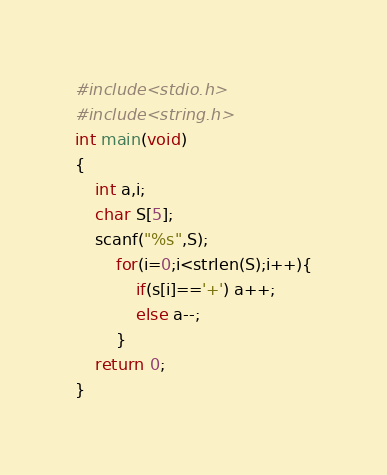<code> <loc_0><loc_0><loc_500><loc_500><_C_>#include<stdio.h>
#include<string.h>
int main(void)
{
	int a,i;
	char S[5];
	scanf("%s",S);
		for(i=0;i<strlen(S);i++){
			if(s[i]=='+') a++;
			else a--;
		}
	return 0;
}
</code> 